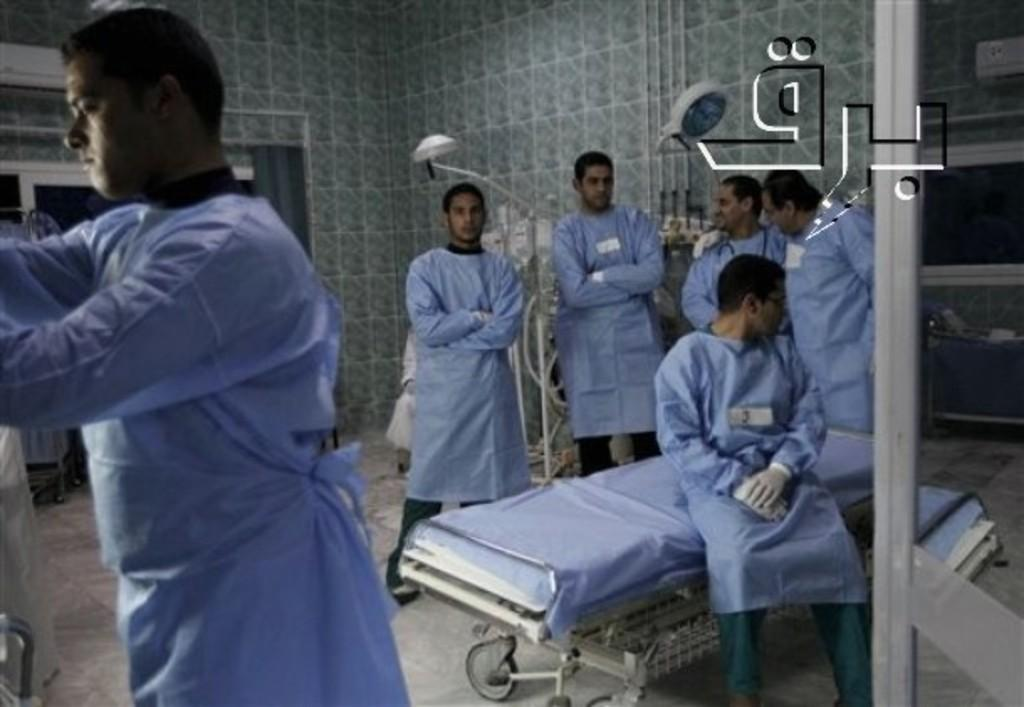What is the main subject of the image? The main subject of the image is a group of people. What are the people in the image doing? The people are standing. What are the people wearing in the image? The people are wearing blue shirts. Can you describe any other objects or elements in the image? There is a bed in the image. What type of recess can be seen in the image? There is no recess present in the image. Can you tell me the name of the mother in the image? There is no mention of a mother or any individual names in the image. 